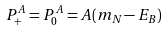Convert formula to latex. <formula><loc_0><loc_0><loc_500><loc_500>P ^ { A } _ { + } = P ^ { A } _ { 0 } = A ( m _ { N } - E _ { B } )</formula> 